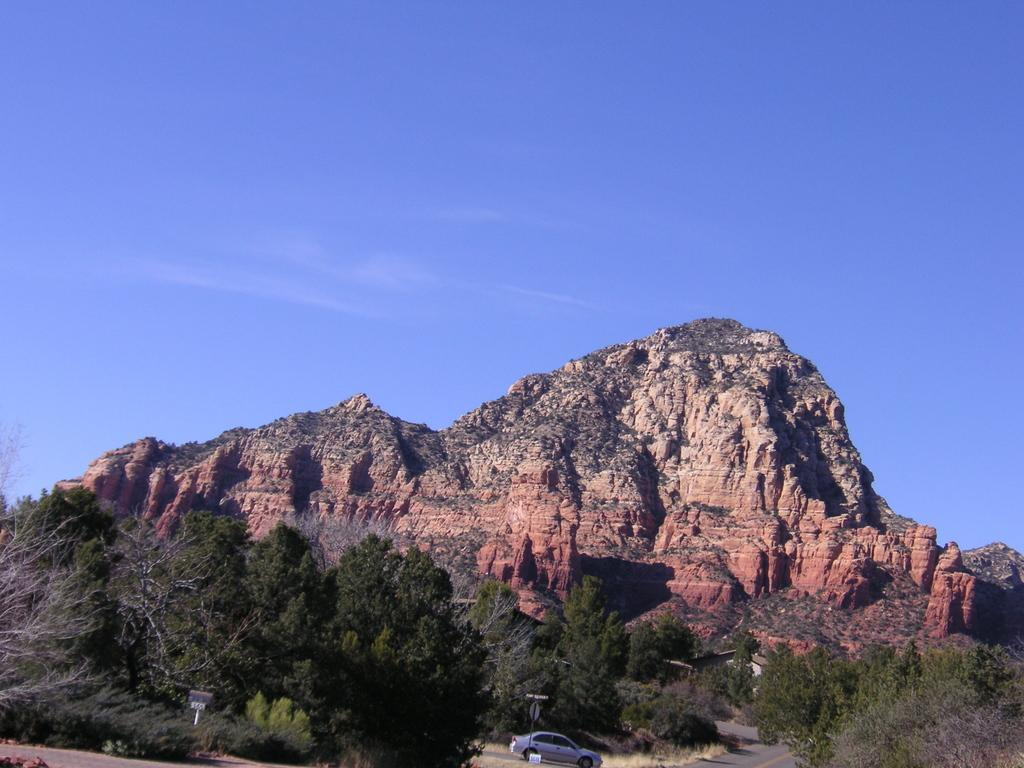What is the main subject of the image? The main subject of the image is a car. What other objects can be seen in the image? There are poles, boards, grass, trees, and a road in the image. What is the background of the image? The background of the image includes a mountain and the sky. What type of terrain is visible in the image? The image shows grass and trees, indicating a natural setting. What type of ticket is the dog holding in the image? There is no dog or ticket present in the image. 